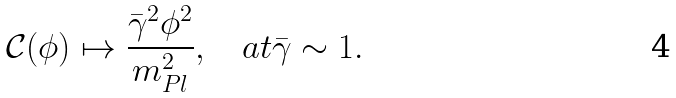<formula> <loc_0><loc_0><loc_500><loc_500>\mathcal { C } ( \phi ) \mapsto \frac { \bar { \gamma } ^ { 2 } \phi ^ { 2 } } { m _ { P l } ^ { 2 } } , \quad a t \bar { \gamma } \sim 1 .</formula> 